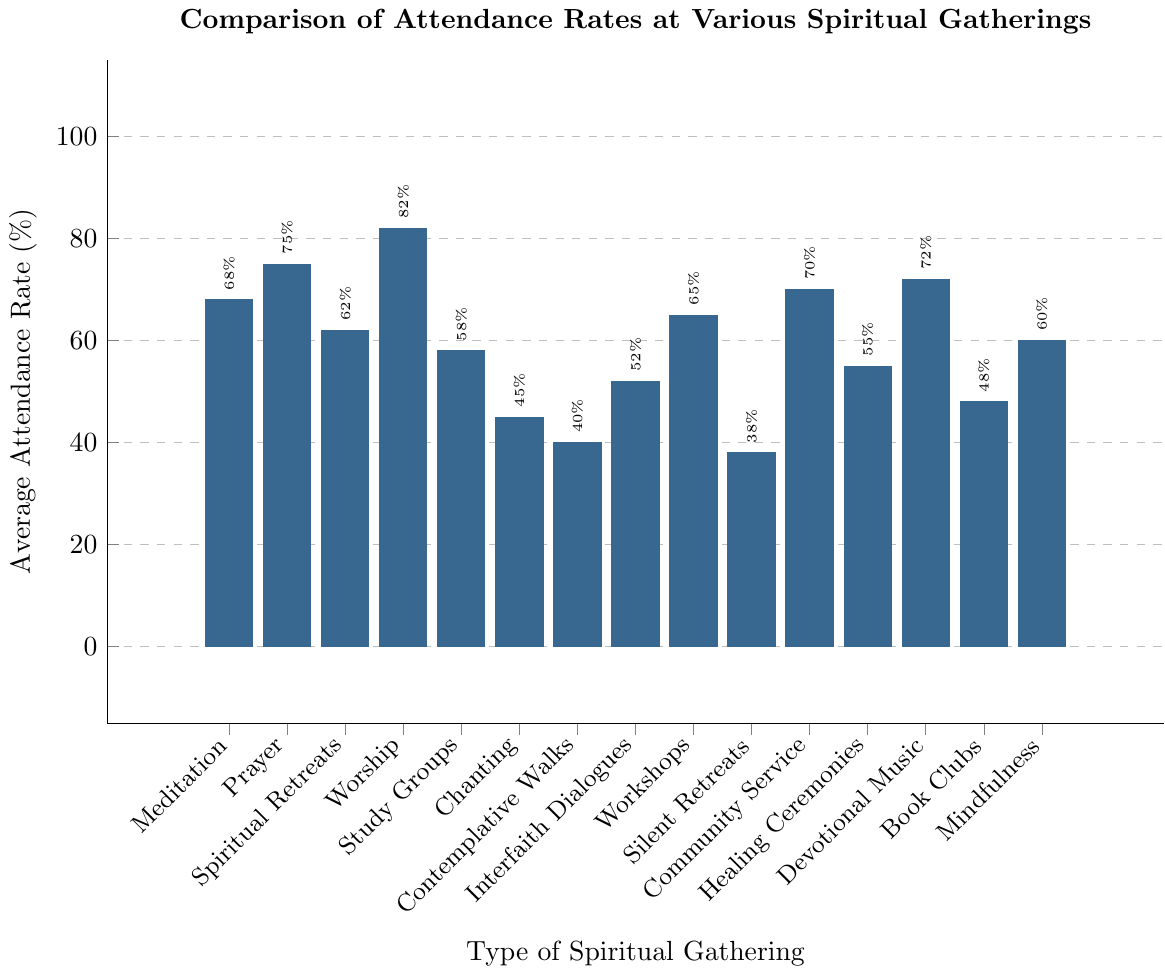Which type of spiritual gathering has the highest average attendance rate? The highest bar represents the gathering with the highest attendance rate. Worship Services has the highest average attendance rate at 82%.
Answer: Worship Services Which type of spiritual gathering has the lowest average attendance rate? The lowest bar represents the gathering with the lowest attendance rate. Silent Retreats has the lowest average attendance rate at 38%.
Answer: Silent Retreats Compare the attendance rate between Meditation Sessions and Prayer Meetings and state which one is higher. By examining the heights of the bars for Meditation Sessions and Prayer Meetings, Prayer Meetings (75%) have a higher attendance rate compared to Meditation Sessions (68%).
Answer: Prayer Meetings What is the attendance rate difference between Community Service Projects and Healing Ceremonies? Subtract the attendance rate of Healing Ceremonies (55%) from Community Service Projects (70%): 70 - 55 = 15.
Answer: 15% What's the average attendance rate of all types of spiritual gatherings shown in the chart? Sum all attendance rates and divide by the number of types. The sum is 981 (68+75+62+82+58+45+40+52+65+38+70+55+72+48+60) and there are 15 types: 981 / 15 = 65.4%.
Answer: 65.4% Which two types of spiritual gatherings have the same average attendance rate? By visually comparing the heights of the bars, no two bars are exactly identical in height, indicating no two types share the same attendance rate.
Answer: None Are more people attending Mindfulness Classes or Spiritual Retreats? Comparing the heights of the bars for Mindfulness Classes (60%) and Spiritual Retreats (62%), more people attend Spiritual Retreats.
Answer: Spiritual Retreats List all spiritual gatherings with an attendance rate above 70%. Identify the bars exceeding the 70% mark: Prayer Meetings (75%), Worship Services (82%), Community Service Projects (70%), and Devotional Music Events (72%).
Answer: Prayer Meetings, Worship Services, Community Service Projects, Devotional Music Events How does the attendance rate of Interfaith Dialogues compare to Study Groups? Compare the heights of the respective bars: Interfaith Dialogues have an attendance rate of 52% and Study Groups have a rate of 58%, making Study Groups' attendance rate higher.
Answer: Study Groups What's the combined attendance rate of Chanting Circles, Silent Retreats, and Contemplative Walks? Add the rates of Chanting Circles (45%), Silent Retreats (38%), and Contemplative Walks (40%): 45 + 38 + 40 = 123.
Answer: 123% 